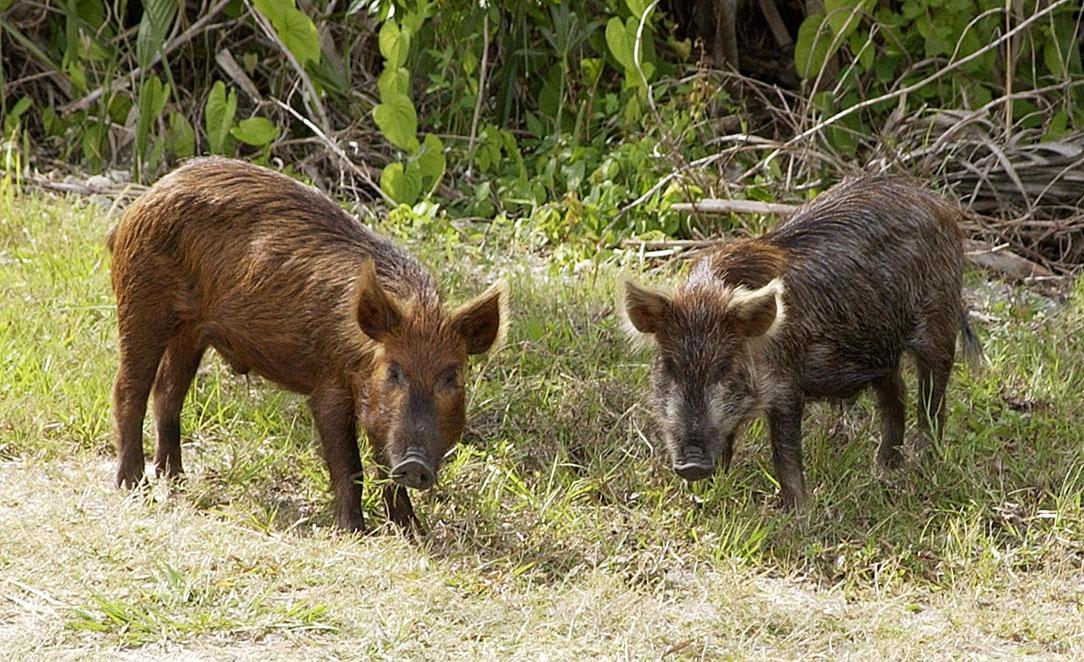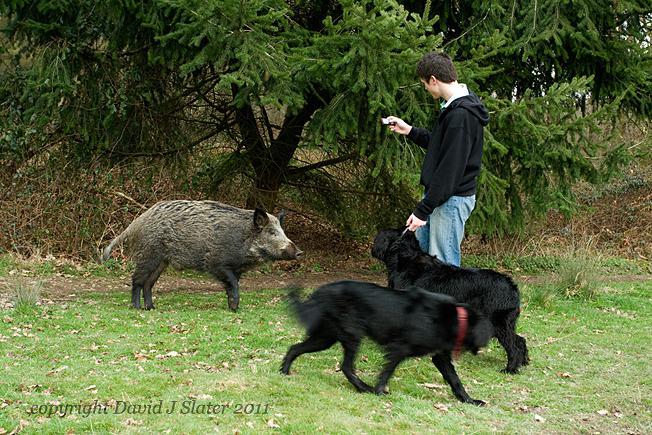The first image is the image on the left, the second image is the image on the right. Examine the images to the left and right. Is the description "There is at least one dog in the right image." accurate? Answer yes or no. Yes. 